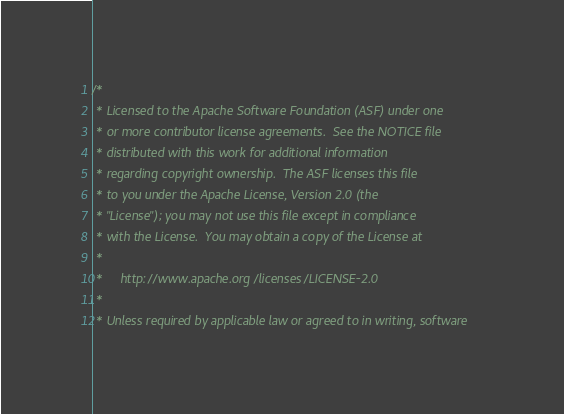<code> <loc_0><loc_0><loc_500><loc_500><_Scala_>/*
 * Licensed to the Apache Software Foundation (ASF) under one
 * or more contributor license agreements.  See the NOTICE file
 * distributed with this work for additional information
 * regarding copyright ownership.  The ASF licenses this file
 * to you under the Apache License, Version 2.0 (the
 * "License"); you may not use this file except in compliance
 * with the License.  You may obtain a copy of the License at
 *
 *     http://www.apache.org/licenses/LICENSE-2.0
 *
 * Unless required by applicable law or agreed to in writing, software</code> 